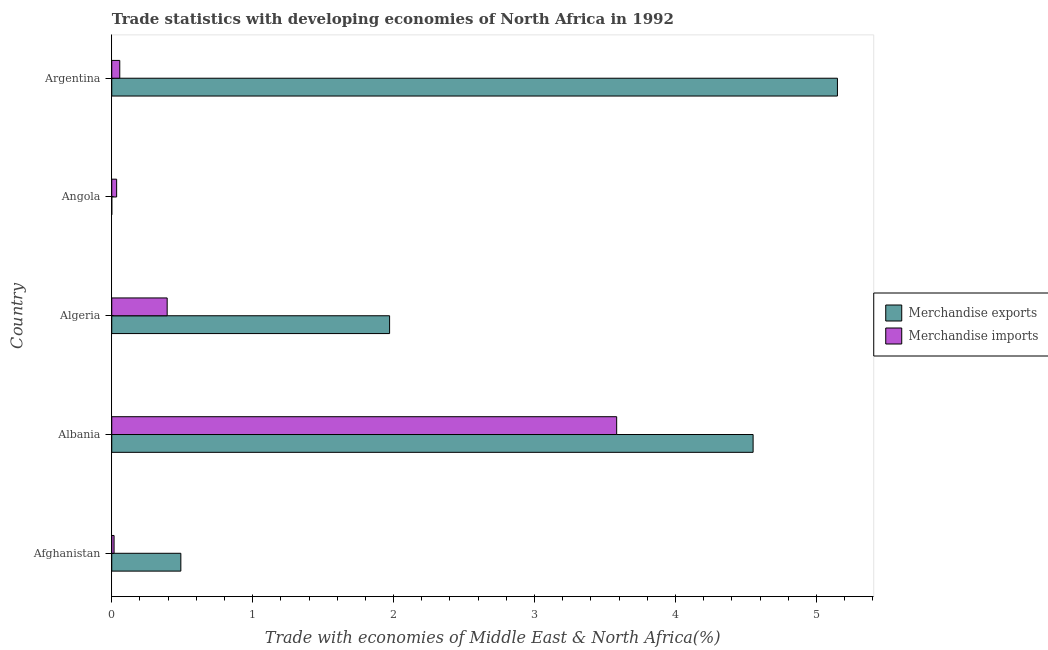How many different coloured bars are there?
Ensure brevity in your answer.  2. How many bars are there on the 2nd tick from the top?
Offer a terse response. 2. What is the label of the 5th group of bars from the top?
Keep it short and to the point. Afghanistan. In how many cases, is the number of bars for a given country not equal to the number of legend labels?
Give a very brief answer. 0. What is the merchandise exports in Albania?
Offer a very short reply. 4.55. Across all countries, what is the maximum merchandise exports?
Offer a terse response. 5.15. Across all countries, what is the minimum merchandise exports?
Your answer should be very brief. 2.838282814677429e-5. In which country was the merchandise imports maximum?
Keep it short and to the point. Albania. In which country was the merchandise exports minimum?
Offer a terse response. Angola. What is the total merchandise imports in the graph?
Offer a very short reply. 4.08. What is the difference between the merchandise exports in Afghanistan and that in Argentina?
Provide a succinct answer. -4.66. What is the difference between the merchandise exports in Argentina and the merchandise imports in Angola?
Offer a very short reply. 5.11. What is the average merchandise imports per country?
Offer a terse response. 0.82. What is the difference between the merchandise exports and merchandise imports in Angola?
Provide a succinct answer. -0.04. What is the ratio of the merchandise imports in Afghanistan to that in Algeria?
Your response must be concise. 0.04. Is the merchandise exports in Albania less than that in Angola?
Your answer should be compact. No. What is the difference between the highest and the second highest merchandise imports?
Provide a succinct answer. 3.19. What is the difference between the highest and the lowest merchandise imports?
Your response must be concise. 3.57. What does the 1st bar from the top in Albania represents?
Ensure brevity in your answer.  Merchandise imports. How many countries are there in the graph?
Ensure brevity in your answer.  5. What is the difference between two consecutive major ticks on the X-axis?
Ensure brevity in your answer.  1. Are the values on the major ticks of X-axis written in scientific E-notation?
Your response must be concise. No. Where does the legend appear in the graph?
Provide a short and direct response. Center right. What is the title of the graph?
Provide a short and direct response. Trade statistics with developing economies of North Africa in 1992. What is the label or title of the X-axis?
Provide a succinct answer. Trade with economies of Middle East & North Africa(%). What is the Trade with economies of Middle East & North Africa(%) in Merchandise exports in Afghanistan?
Ensure brevity in your answer.  0.49. What is the Trade with economies of Middle East & North Africa(%) in Merchandise imports in Afghanistan?
Offer a terse response. 0.02. What is the Trade with economies of Middle East & North Africa(%) of Merchandise exports in Albania?
Keep it short and to the point. 4.55. What is the Trade with economies of Middle East & North Africa(%) in Merchandise imports in Albania?
Give a very brief answer. 3.58. What is the Trade with economies of Middle East & North Africa(%) of Merchandise exports in Algeria?
Provide a succinct answer. 1.97. What is the Trade with economies of Middle East & North Africa(%) of Merchandise imports in Algeria?
Offer a terse response. 0.39. What is the Trade with economies of Middle East & North Africa(%) in Merchandise exports in Angola?
Your answer should be compact. 2.838282814677429e-5. What is the Trade with economies of Middle East & North Africa(%) of Merchandise imports in Angola?
Keep it short and to the point. 0.03. What is the Trade with economies of Middle East & North Africa(%) in Merchandise exports in Argentina?
Provide a succinct answer. 5.15. What is the Trade with economies of Middle East & North Africa(%) of Merchandise imports in Argentina?
Provide a short and direct response. 0.06. Across all countries, what is the maximum Trade with economies of Middle East & North Africa(%) in Merchandise exports?
Offer a very short reply. 5.15. Across all countries, what is the maximum Trade with economies of Middle East & North Africa(%) of Merchandise imports?
Keep it short and to the point. 3.58. Across all countries, what is the minimum Trade with economies of Middle East & North Africa(%) of Merchandise exports?
Offer a very short reply. 2.838282814677429e-5. Across all countries, what is the minimum Trade with economies of Middle East & North Africa(%) of Merchandise imports?
Your answer should be very brief. 0.02. What is the total Trade with economies of Middle East & North Africa(%) of Merchandise exports in the graph?
Provide a succinct answer. 12.16. What is the total Trade with economies of Middle East & North Africa(%) in Merchandise imports in the graph?
Your answer should be very brief. 4.08. What is the difference between the Trade with economies of Middle East & North Africa(%) in Merchandise exports in Afghanistan and that in Albania?
Offer a terse response. -4.06. What is the difference between the Trade with economies of Middle East & North Africa(%) of Merchandise imports in Afghanistan and that in Albania?
Provide a succinct answer. -3.57. What is the difference between the Trade with economies of Middle East & North Africa(%) of Merchandise exports in Afghanistan and that in Algeria?
Your response must be concise. -1.48. What is the difference between the Trade with economies of Middle East & North Africa(%) in Merchandise imports in Afghanistan and that in Algeria?
Provide a succinct answer. -0.38. What is the difference between the Trade with economies of Middle East & North Africa(%) in Merchandise exports in Afghanistan and that in Angola?
Offer a very short reply. 0.49. What is the difference between the Trade with economies of Middle East & North Africa(%) of Merchandise imports in Afghanistan and that in Angola?
Provide a succinct answer. -0.02. What is the difference between the Trade with economies of Middle East & North Africa(%) of Merchandise exports in Afghanistan and that in Argentina?
Keep it short and to the point. -4.66. What is the difference between the Trade with economies of Middle East & North Africa(%) in Merchandise imports in Afghanistan and that in Argentina?
Your response must be concise. -0.04. What is the difference between the Trade with economies of Middle East & North Africa(%) in Merchandise exports in Albania and that in Algeria?
Provide a succinct answer. 2.58. What is the difference between the Trade with economies of Middle East & North Africa(%) in Merchandise imports in Albania and that in Algeria?
Your answer should be very brief. 3.19. What is the difference between the Trade with economies of Middle East & North Africa(%) in Merchandise exports in Albania and that in Angola?
Keep it short and to the point. 4.55. What is the difference between the Trade with economies of Middle East & North Africa(%) of Merchandise imports in Albania and that in Angola?
Ensure brevity in your answer.  3.55. What is the difference between the Trade with economies of Middle East & North Africa(%) in Merchandise exports in Albania and that in Argentina?
Ensure brevity in your answer.  -0.6. What is the difference between the Trade with economies of Middle East & North Africa(%) of Merchandise imports in Albania and that in Argentina?
Your answer should be very brief. 3.53. What is the difference between the Trade with economies of Middle East & North Africa(%) of Merchandise exports in Algeria and that in Angola?
Make the answer very short. 1.97. What is the difference between the Trade with economies of Middle East & North Africa(%) of Merchandise imports in Algeria and that in Angola?
Your answer should be compact. 0.36. What is the difference between the Trade with economies of Middle East & North Africa(%) in Merchandise exports in Algeria and that in Argentina?
Make the answer very short. -3.18. What is the difference between the Trade with economies of Middle East & North Africa(%) of Merchandise imports in Algeria and that in Argentina?
Provide a short and direct response. 0.34. What is the difference between the Trade with economies of Middle East & North Africa(%) of Merchandise exports in Angola and that in Argentina?
Keep it short and to the point. -5.15. What is the difference between the Trade with economies of Middle East & North Africa(%) of Merchandise imports in Angola and that in Argentina?
Offer a terse response. -0.02. What is the difference between the Trade with economies of Middle East & North Africa(%) of Merchandise exports in Afghanistan and the Trade with economies of Middle East & North Africa(%) of Merchandise imports in Albania?
Make the answer very short. -3.09. What is the difference between the Trade with economies of Middle East & North Africa(%) in Merchandise exports in Afghanistan and the Trade with economies of Middle East & North Africa(%) in Merchandise imports in Algeria?
Give a very brief answer. 0.1. What is the difference between the Trade with economies of Middle East & North Africa(%) in Merchandise exports in Afghanistan and the Trade with economies of Middle East & North Africa(%) in Merchandise imports in Angola?
Provide a succinct answer. 0.46. What is the difference between the Trade with economies of Middle East & North Africa(%) in Merchandise exports in Afghanistan and the Trade with economies of Middle East & North Africa(%) in Merchandise imports in Argentina?
Offer a very short reply. 0.43. What is the difference between the Trade with economies of Middle East & North Africa(%) of Merchandise exports in Albania and the Trade with economies of Middle East & North Africa(%) of Merchandise imports in Algeria?
Your answer should be very brief. 4.16. What is the difference between the Trade with economies of Middle East & North Africa(%) in Merchandise exports in Albania and the Trade with economies of Middle East & North Africa(%) in Merchandise imports in Angola?
Ensure brevity in your answer.  4.52. What is the difference between the Trade with economies of Middle East & North Africa(%) in Merchandise exports in Albania and the Trade with economies of Middle East & North Africa(%) in Merchandise imports in Argentina?
Your answer should be compact. 4.49. What is the difference between the Trade with economies of Middle East & North Africa(%) in Merchandise exports in Algeria and the Trade with economies of Middle East & North Africa(%) in Merchandise imports in Angola?
Make the answer very short. 1.94. What is the difference between the Trade with economies of Middle East & North Africa(%) in Merchandise exports in Algeria and the Trade with economies of Middle East & North Africa(%) in Merchandise imports in Argentina?
Make the answer very short. 1.91. What is the difference between the Trade with economies of Middle East & North Africa(%) in Merchandise exports in Angola and the Trade with economies of Middle East & North Africa(%) in Merchandise imports in Argentina?
Provide a succinct answer. -0.06. What is the average Trade with economies of Middle East & North Africa(%) in Merchandise exports per country?
Provide a succinct answer. 2.43. What is the average Trade with economies of Middle East & North Africa(%) of Merchandise imports per country?
Provide a succinct answer. 0.82. What is the difference between the Trade with economies of Middle East & North Africa(%) of Merchandise exports and Trade with economies of Middle East & North Africa(%) of Merchandise imports in Afghanistan?
Keep it short and to the point. 0.47. What is the difference between the Trade with economies of Middle East & North Africa(%) in Merchandise exports and Trade with economies of Middle East & North Africa(%) in Merchandise imports in Albania?
Provide a short and direct response. 0.97. What is the difference between the Trade with economies of Middle East & North Africa(%) of Merchandise exports and Trade with economies of Middle East & North Africa(%) of Merchandise imports in Algeria?
Give a very brief answer. 1.58. What is the difference between the Trade with economies of Middle East & North Africa(%) in Merchandise exports and Trade with economies of Middle East & North Africa(%) in Merchandise imports in Angola?
Give a very brief answer. -0.03. What is the difference between the Trade with economies of Middle East & North Africa(%) in Merchandise exports and Trade with economies of Middle East & North Africa(%) in Merchandise imports in Argentina?
Give a very brief answer. 5.09. What is the ratio of the Trade with economies of Middle East & North Africa(%) of Merchandise exports in Afghanistan to that in Albania?
Provide a short and direct response. 0.11. What is the ratio of the Trade with economies of Middle East & North Africa(%) of Merchandise imports in Afghanistan to that in Albania?
Offer a terse response. 0. What is the ratio of the Trade with economies of Middle East & North Africa(%) of Merchandise exports in Afghanistan to that in Algeria?
Keep it short and to the point. 0.25. What is the ratio of the Trade with economies of Middle East & North Africa(%) of Merchandise imports in Afghanistan to that in Algeria?
Your answer should be compact. 0.04. What is the ratio of the Trade with economies of Middle East & North Africa(%) in Merchandise exports in Afghanistan to that in Angola?
Your answer should be compact. 1.73e+04. What is the ratio of the Trade with economies of Middle East & North Africa(%) in Merchandise imports in Afghanistan to that in Angola?
Provide a succinct answer. 0.48. What is the ratio of the Trade with economies of Middle East & North Africa(%) of Merchandise exports in Afghanistan to that in Argentina?
Provide a succinct answer. 0.1. What is the ratio of the Trade with economies of Middle East & North Africa(%) of Merchandise imports in Afghanistan to that in Argentina?
Ensure brevity in your answer.  0.29. What is the ratio of the Trade with economies of Middle East & North Africa(%) of Merchandise exports in Albania to that in Algeria?
Provide a succinct answer. 2.31. What is the ratio of the Trade with economies of Middle East & North Africa(%) in Merchandise imports in Albania to that in Algeria?
Offer a very short reply. 9.11. What is the ratio of the Trade with economies of Middle East & North Africa(%) of Merchandise exports in Albania to that in Angola?
Offer a very short reply. 1.60e+05. What is the ratio of the Trade with economies of Middle East & North Africa(%) in Merchandise imports in Albania to that in Angola?
Provide a short and direct response. 103.32. What is the ratio of the Trade with economies of Middle East & North Africa(%) in Merchandise exports in Albania to that in Argentina?
Make the answer very short. 0.88. What is the ratio of the Trade with economies of Middle East & North Africa(%) in Merchandise imports in Albania to that in Argentina?
Offer a terse response. 63.03. What is the ratio of the Trade with economies of Middle East & North Africa(%) of Merchandise exports in Algeria to that in Angola?
Give a very brief answer. 6.95e+04. What is the ratio of the Trade with economies of Middle East & North Africa(%) of Merchandise imports in Algeria to that in Angola?
Make the answer very short. 11.34. What is the ratio of the Trade with economies of Middle East & North Africa(%) of Merchandise exports in Algeria to that in Argentina?
Your answer should be very brief. 0.38. What is the ratio of the Trade with economies of Middle East & North Africa(%) in Merchandise imports in Algeria to that in Argentina?
Ensure brevity in your answer.  6.92. What is the ratio of the Trade with economies of Middle East & North Africa(%) of Merchandise imports in Angola to that in Argentina?
Provide a short and direct response. 0.61. What is the difference between the highest and the second highest Trade with economies of Middle East & North Africa(%) in Merchandise exports?
Provide a succinct answer. 0.6. What is the difference between the highest and the second highest Trade with economies of Middle East & North Africa(%) of Merchandise imports?
Your response must be concise. 3.19. What is the difference between the highest and the lowest Trade with economies of Middle East & North Africa(%) in Merchandise exports?
Your answer should be compact. 5.15. What is the difference between the highest and the lowest Trade with economies of Middle East & North Africa(%) of Merchandise imports?
Provide a short and direct response. 3.57. 